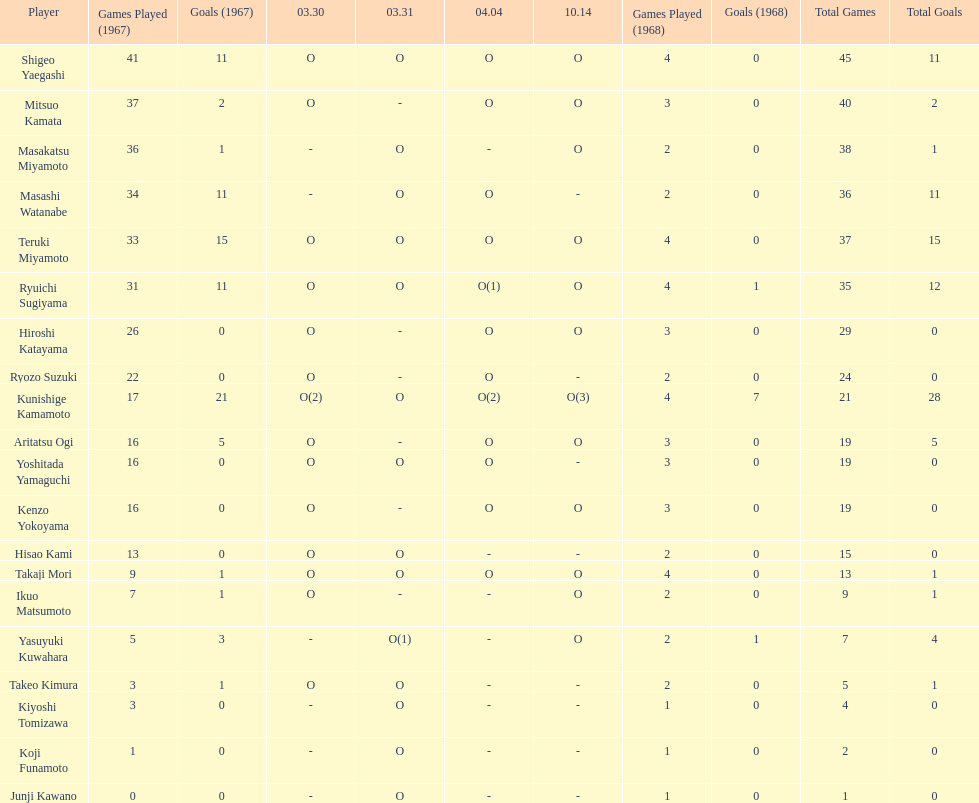Did mitsuo kamata have more than 40 total points? No. 